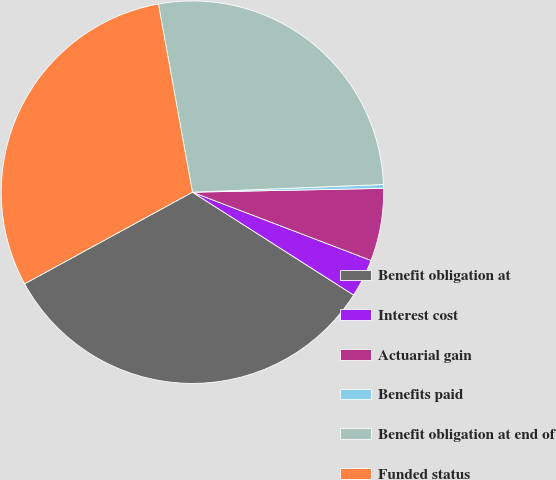Convert chart to OTSL. <chart><loc_0><loc_0><loc_500><loc_500><pie_chart><fcel>Benefit obligation at<fcel>Interest cost<fcel>Actuarial gain<fcel>Benefits paid<fcel>Benefit obligation at end of<fcel>Funded status<nl><fcel>33.01%<fcel>3.23%<fcel>6.13%<fcel>0.32%<fcel>27.21%<fcel>30.11%<nl></chart> 